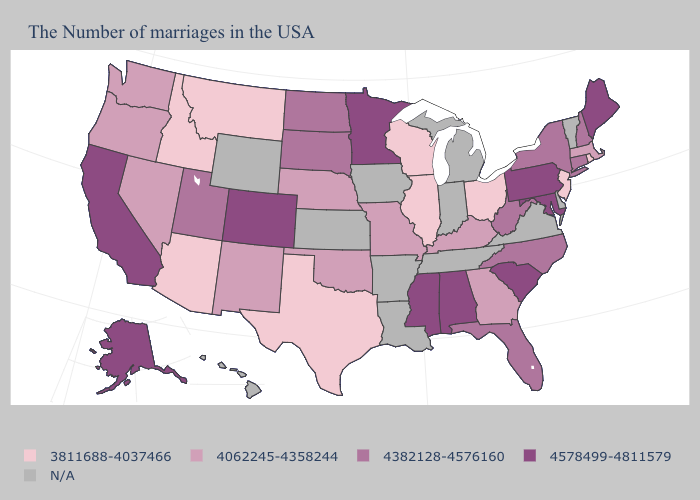Does Rhode Island have the lowest value in the USA?
Short answer required. Yes. Among the states that border Florida , which have the highest value?
Short answer required. Alabama. Name the states that have a value in the range 4062245-4358244?
Be succinct. Massachusetts, Georgia, Kentucky, Missouri, Nebraska, Oklahoma, New Mexico, Nevada, Washington, Oregon. What is the value of New Jersey?
Be succinct. 3811688-4037466. Name the states that have a value in the range 4382128-4576160?
Short answer required. New Hampshire, Connecticut, New York, North Carolina, West Virginia, Florida, South Dakota, North Dakota, Utah. Among the states that border Arkansas , does Oklahoma have the highest value?
Answer briefly. No. Among the states that border Rhode Island , does Massachusetts have the highest value?
Concise answer only. No. What is the highest value in the USA?
Be succinct. 4578499-4811579. Name the states that have a value in the range 4578499-4811579?
Quick response, please. Maine, Maryland, Pennsylvania, South Carolina, Alabama, Mississippi, Minnesota, Colorado, California, Alaska. What is the highest value in the USA?
Give a very brief answer. 4578499-4811579. Is the legend a continuous bar?
Give a very brief answer. No. Name the states that have a value in the range 4578499-4811579?
Answer briefly. Maine, Maryland, Pennsylvania, South Carolina, Alabama, Mississippi, Minnesota, Colorado, California, Alaska. How many symbols are there in the legend?
Short answer required. 5. Name the states that have a value in the range 4062245-4358244?
Answer briefly. Massachusetts, Georgia, Kentucky, Missouri, Nebraska, Oklahoma, New Mexico, Nevada, Washington, Oregon. What is the lowest value in the USA?
Short answer required. 3811688-4037466. 